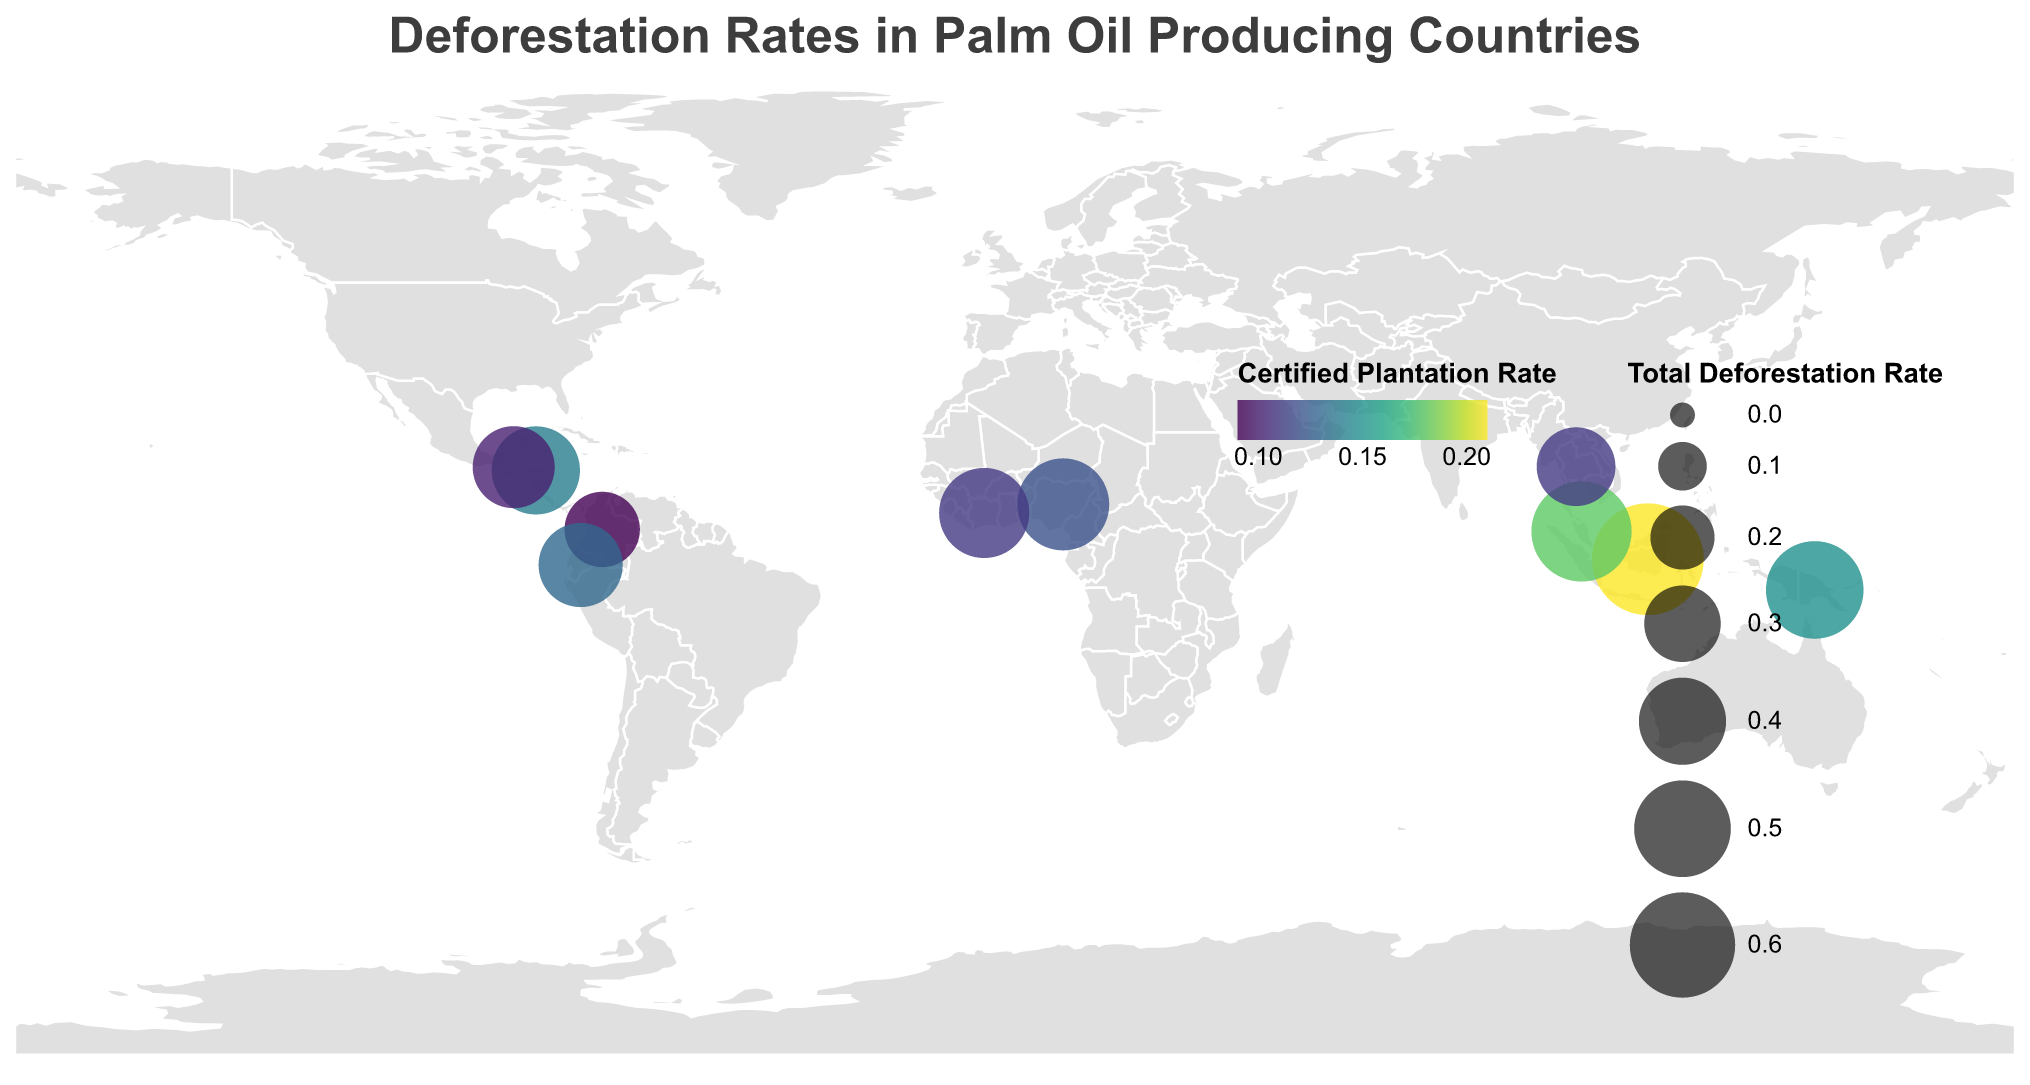Which country has the highest total deforestation rate? The largest circle on the map indicates the highest total deforestation rate, which corresponds to Indonesia.
Answer: Indonesia How does the certified plantation rate in Malaysia compare to that in Thailand? The color of the circles indicates the certified plantation rates. Malaysia has a darker shade of green compared to Thailand, representing higher certified plantation rates. Specifically, Malaysia's certified plantation rate is 0.18, while Thailand's is 0.11.
Answer: Malaysia is higher What is the difference in the non-certified plantation rate between Colombia and Nigeria? By looking at the tooltip for the respective countries, Colombia has a non-certified rate of 0.20 and Nigeria has 0.33. Subtracting the two rates gives 0.33 - 0.20 = 0.13.
Answer: 0.13 Which country in Central America has a higher certified plantation rate, Honduras or Guatemala? The tooltip or the green shades on the countries in Central America reveal that Honduras has a certified rate of 0.14 while Guatemala has 0.10.
Answer: Honduras What is the average certified plantation rate across all countries displayed? Adding up the certified plantation rates for all 10 countries (0.21+0.18+0.11+0.09+0.12+0.15+0.13+0.14+0.10+0.11) gives a total of 1.34. Dividing by 10 yields an average certified plantation rate of 0.134.
Answer: 0.134 Which African country has a higher total deforestation rate, Nigeria or Côte d'Ivoire? The circle sizes for Nigeria and Côte d'Ivoire indicate their total deforestation rates. Nigeria's rate is 0.45, while Côte d'Ivoire's is 0.43.
Answer: Nigeria How does the total deforestation rate in Papua New Guinea compare with the certified plantation rate in the same country? The tooltip for Papua New Guinea shows a total deforestation rate of 0.51 and a certified plantation rate of 0.15.
Answer: The total deforestation rate is higher What is the combined total deforestation rate of Indonesia and Malaysia? Adding the total deforestation rates of Indonesia (0.68) and Malaysia (0.54) gives 0.68 + 0.54 = 1.22.
Answer: 1.22 Which two countries have an equal certified plantation rate of 0.11? By examining the tooltips, both Thailand and Côte d'Ivoire have a certified plantation rate of 0.11.
Answer: Thailand and Côte d'Ivoire 